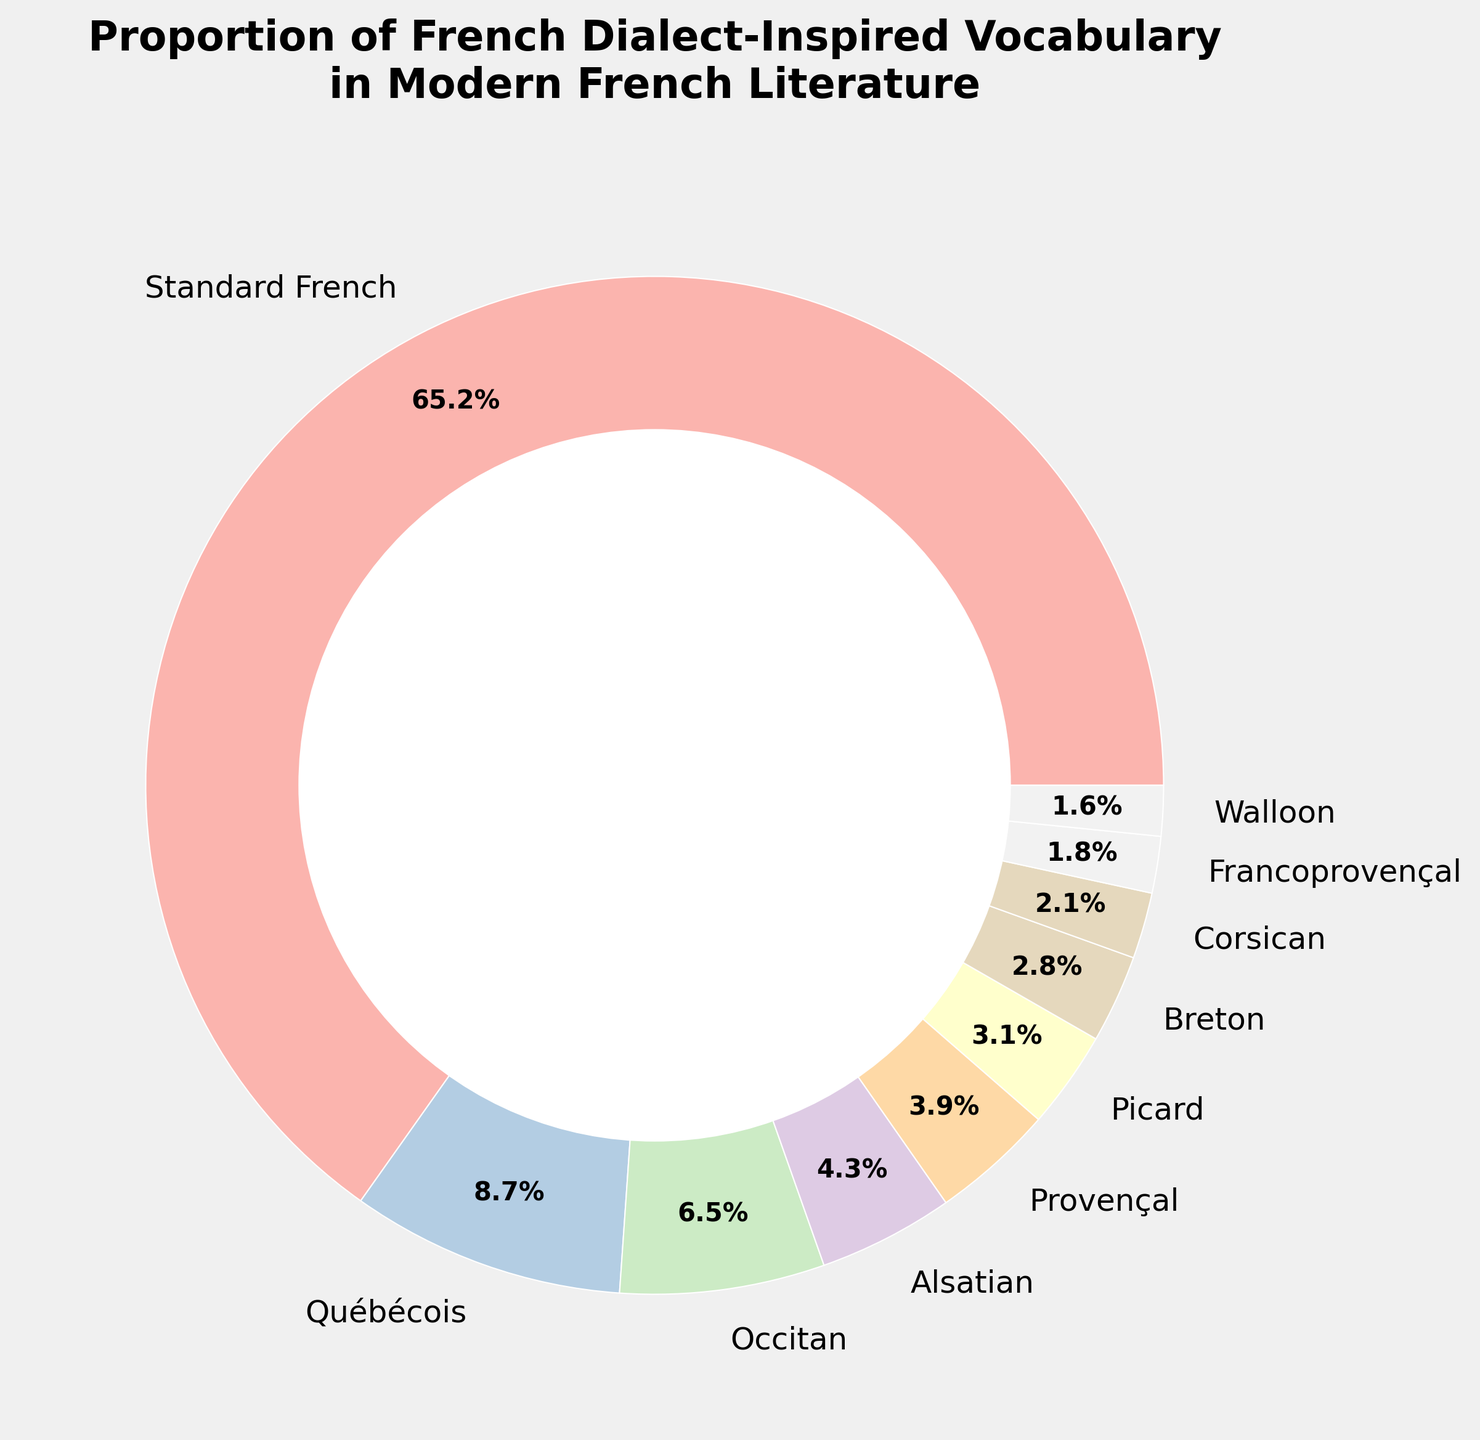Which dialect contributes the most to the modern French literature vocabulary? By observing the pie chart, we can see that the largest section is labeled "Standard French," indicating it has the highest percentage at 65.2%.
Answer: Standard French What is the combined percentage of Occitan and Provençal dialects? According to the pie chart, the Occitan dialect contributes 6.5% and the Provençal dialect contributes 3.9%. Adding these together, we get 6.5% + 3.9% = 10.4%.
Answer: 10.4% Which dialect has a larger proportion, Breton or Corsican? By looking at the pie chart, we see that the Breton section is 2.8% and the Corsican section is 2.1%. Therefore, Breton has a larger proportion.
Answer: Breton How many dialects contribute less than 5% each? Observing the pie chart, we sum the individual contributions: Alsatian (4.3%), Provençal (3.9%), Picard (3.1%), Breton (2.8%), Corsican (2.1%), Francoprovençal (1.8%), Walloon (1.6%). Counting these, we find 7 dialects.
Answer: 7 What is the ratio of the percentage contributions of Québécois to Alsatian? From the pie chart, Québécois contributes 8.7% and Alsatian contributes 4.3%. The ratio is calculated as 8.7 / 4.3, which simplifies to approximately 2.02.
Answer: 2.02 Which two dialects have the smallest and largest contributions respectively? Observing the pie chart, the smallest contribution is from Walloon at 1.6%, and the largest is from Standard French at 65.2%.
Answer: Walloon, Standard French What is the total percentage of dialects contributing less than 3% each? Summing the percentages from the pie chart: Breton (2.8%), Corsican (2.1%), Francoprovençal (1.8%), Walloon (1.6%) gives us 2.8% + 2.1% + 1.8% + 1.6% = 8.3%.
Answer: 8.3% Which dialect segment appears in yellow on the chart? Based on the visual characteristics described, identifying this relies on the color mapping in the pastel color scheme used. Typically, the chart provides a legend or a way to distinguish visual cues; however, this information isn't available in the text data alone.
Answer: Not specified Which is more prevalent: Picard or Provençal, and by how much? From the pie chart, Picard contributes 3.1% and Provençal contributes 3.9%. The difference is calculated as 3.9% - 3.1% = 0.8%.
Answer: Provençal by 0.8% What percentage of the vocabulary is inspired by dialects other than Standard French? By excluding Standard French's 65.2% from the total 100%, we calculate the remaining contributions as 100% - 65.2% = 34.8%.
Answer: 34.8% 